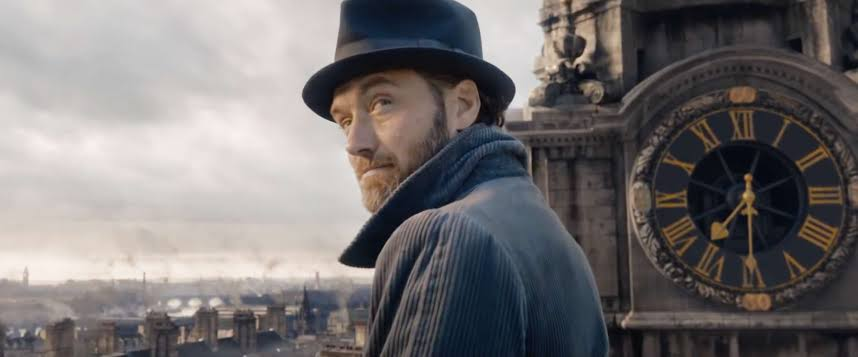How does the setting of the image enhance the mood or theme? The rooftop setting, high above the city with overcast skies and a historical backdrop, enhances the mood of isolation and prominence. It visually amplifies the character's solitude and the significance of his role or decision, situating him both literally and figuratively above the bustling world below, perhaps in contemplation of a heavy, distant responsibility. 